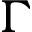<formula> <loc_0><loc_0><loc_500><loc_500>\Gamma</formula> 